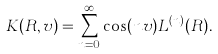<formula> <loc_0><loc_0><loc_500><loc_500>K ( R , v ) = \sum _ { n = 0 } ^ { \infty } \cos ( n v ) L ^ { ( n ) } ( R ) .</formula> 